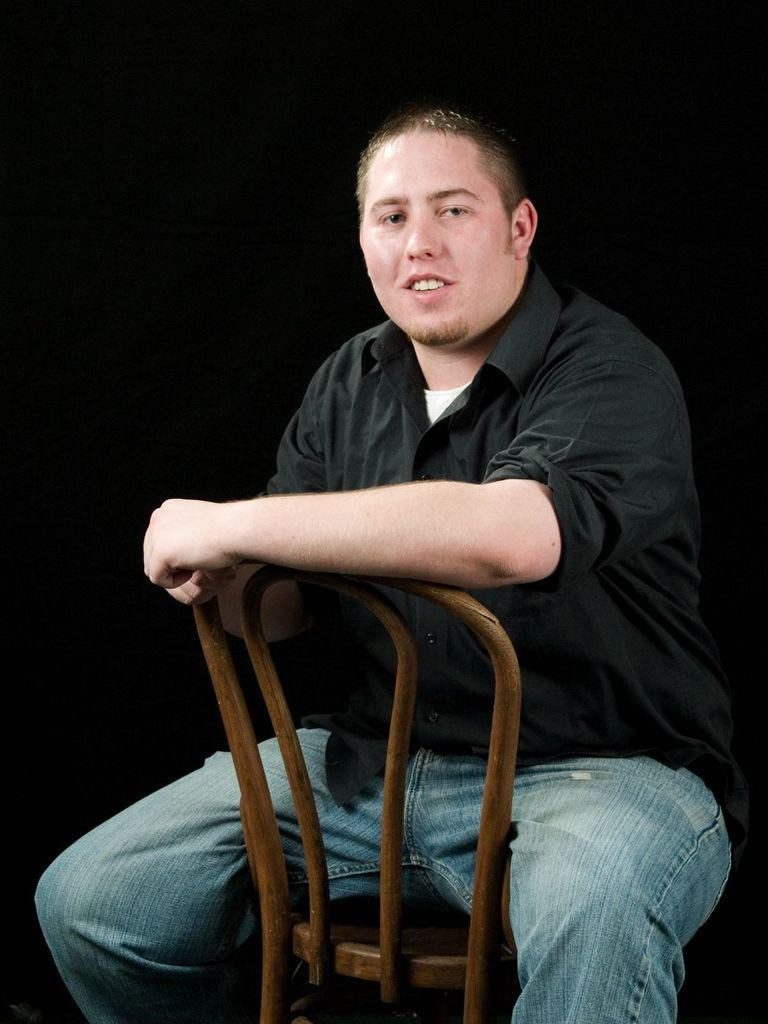What is the main subject of the image? There is a man in the image. What is the man doing in the image? The man is sitting on a chair. What type of shop can be seen in the background of the image? There is no shop visible in the image; it only features a man sitting on a chair. Is the man sinking into quicksand in the image? There is no quicksand present in the image, and the man is sitting on a chair. 